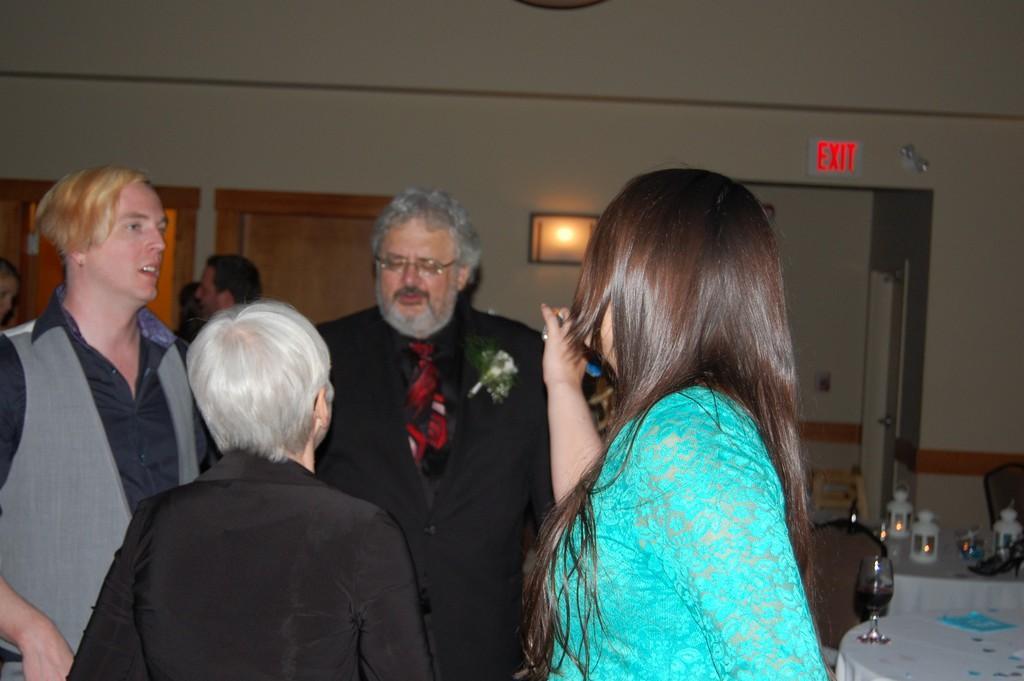How would you summarize this image in a sentence or two? In this image in front there are people. On the right side of the image there are tables. On top of it there are glasses, lamps and a few other objects. In the background of the image there are doors. There is a photo frame and a exit board on the wall. 